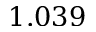<formula> <loc_0><loc_0><loc_500><loc_500>1 . 0 3 9</formula> 